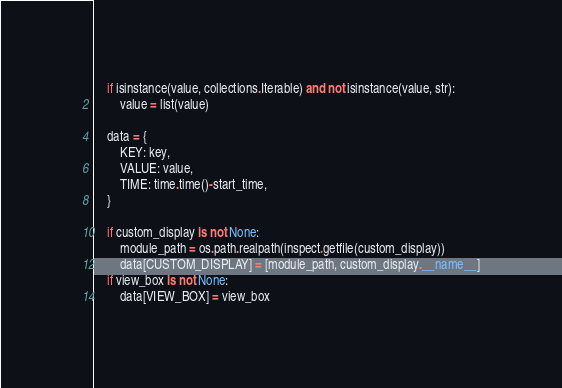<code> <loc_0><loc_0><loc_500><loc_500><_Python_>    if isinstance(value, collections.Iterable) and not isinstance(value, str):
        value = list(value)

    data = {
        KEY: key,
        VALUE: value,
        TIME: time.time()-start_time,
    }

    if custom_display is not None:
        module_path = os.path.realpath(inspect.getfile(custom_display))
        data[CUSTOM_DISPLAY] = [module_path, custom_display.__name__]
    if view_box is not None:
        data[VIEW_BOX] = view_box</code> 